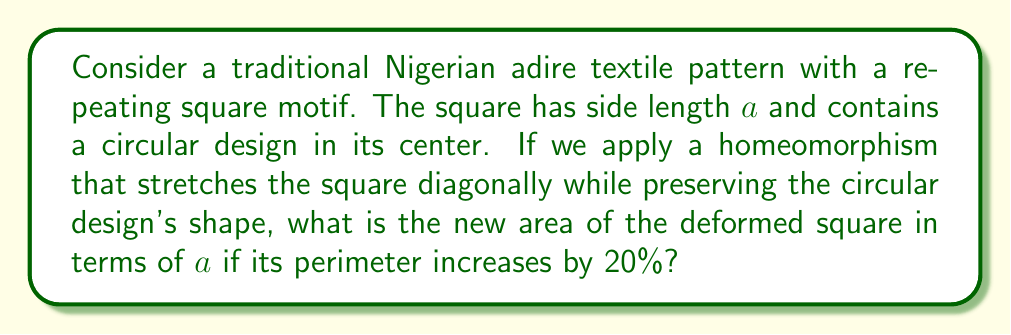What is the answer to this math problem? Let's approach this step-by-step:

1) First, we need to understand what the homeomorphism does. It stretches the square diagonally while preserving the circular design. This means the square becomes a rhombus.

2) The original perimeter of the square is $4a$.

3) After the transformation, the perimeter increases by 20%. So the new perimeter is:

   $4a \times 1.2 = 4.8a$

4) In a rhombus, if we denote the length of each side as $s$, then:

   $4s = 4.8a$
   $s = 1.2a$

5) Now, we need to find the area of this rhombus. The area of a rhombus is given by the formula:

   $A = d_1d_2/2$

   where $d_1$ and $d_2$ are the diagonals.

6) In our case, one diagonal is stretched and the other is compressed. Let's call the longer diagonal $d_1$ and the shorter $d_2$.

7) We can find these diagonals using the Pythagorean theorem:

   $d_1^2 + d_2^2 = 4s^2 = 4(1.2a)^2 = 5.76a^2$

8) Due to the symmetry of the stretching, we can say:

   $d_1d_2 = 2a^2$

9) Substituting this into the area formula:

   $A = d_1d_2/2 = (2a^2)/2 = a^2$

Therefore, despite the stretching, the area remains $a^2$, the same as the original square!

This illustrates an important concept in topology: homeomorphisms preserve certain properties, including the area in this case, even when the shape is deformed.
Answer: $a^2$ 